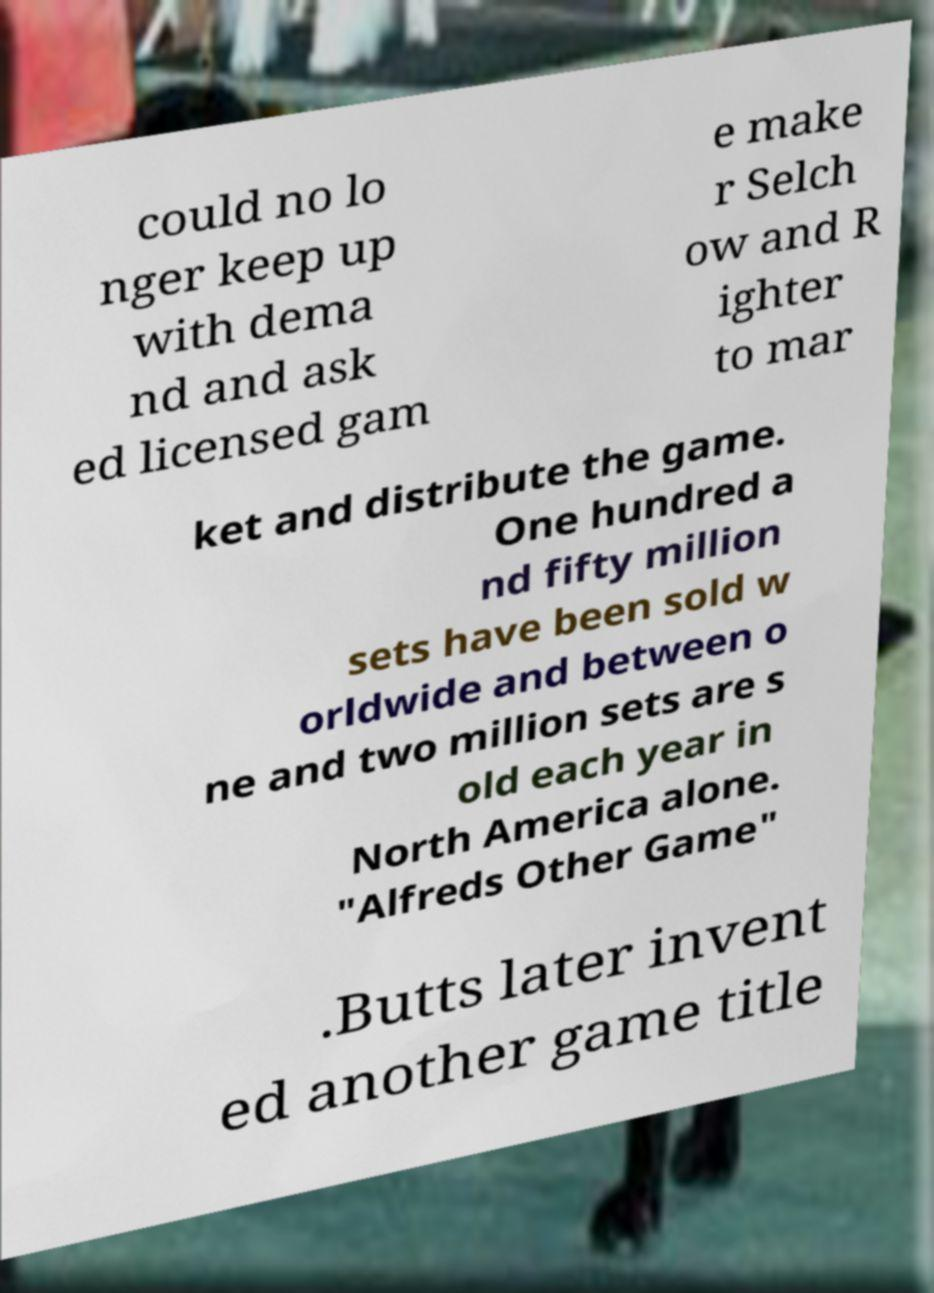Please identify and transcribe the text found in this image. could no lo nger keep up with dema nd and ask ed licensed gam e make r Selch ow and R ighter to mar ket and distribute the game. One hundred a nd fifty million sets have been sold w orldwide and between o ne and two million sets are s old each year in North America alone. "Alfreds Other Game" .Butts later invent ed another game title 